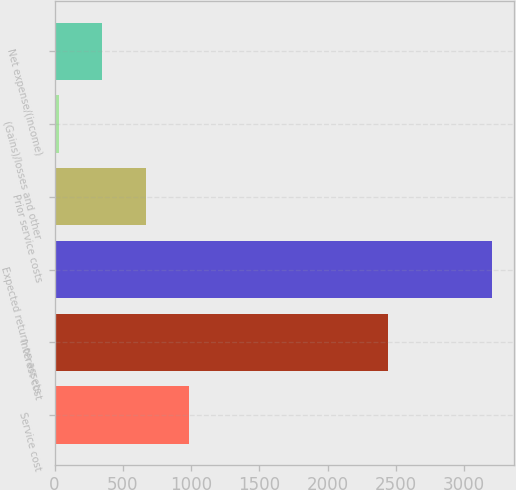<chart> <loc_0><loc_0><loc_500><loc_500><bar_chart><fcel>Service cost<fcel>Interest cost<fcel>Expected return on assets<fcel>Prior service costs<fcel>(Gains)/losses and other<fcel>Net expense/(income)<nl><fcel>983.7<fcel>2442<fcel>3202<fcel>666.8<fcel>33<fcel>349.9<nl></chart> 